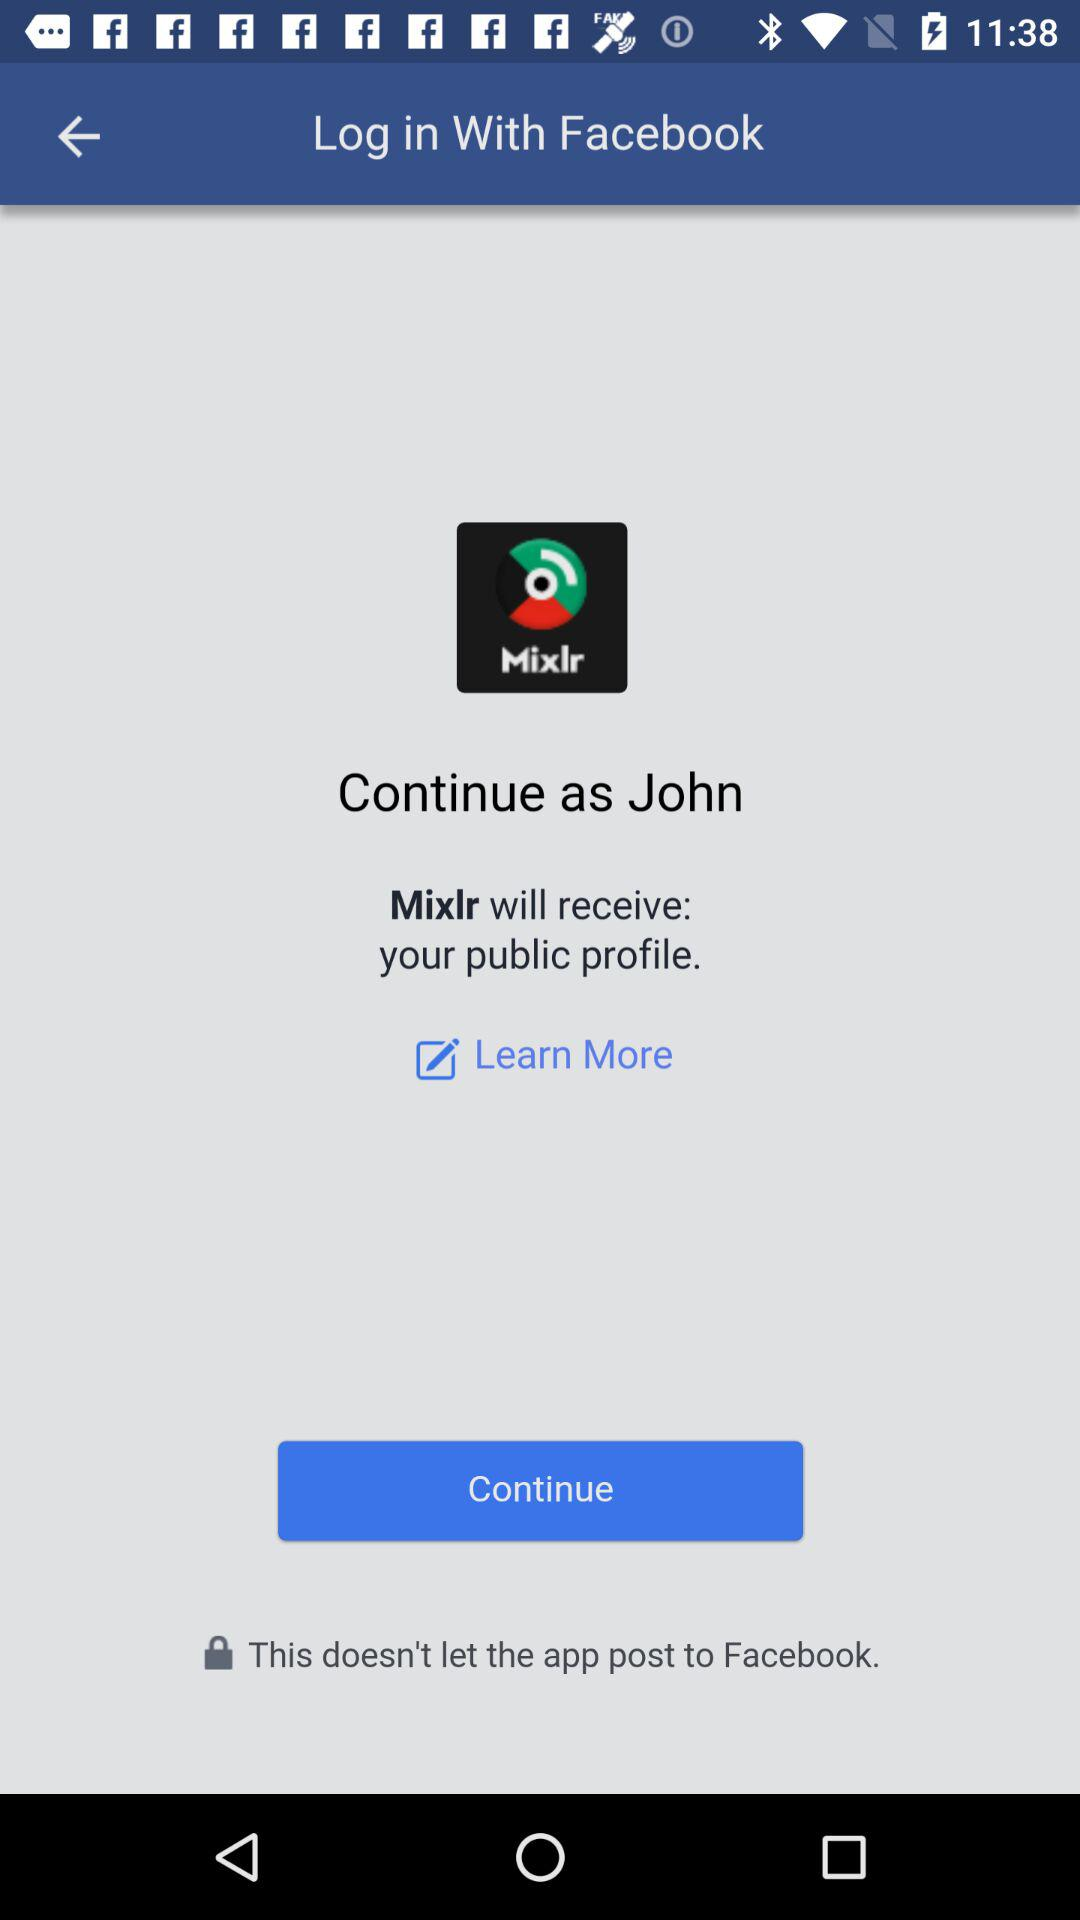What's the application name that will receive the user's public profile? The application name that will receive the user's public profile is "Mixlr". 